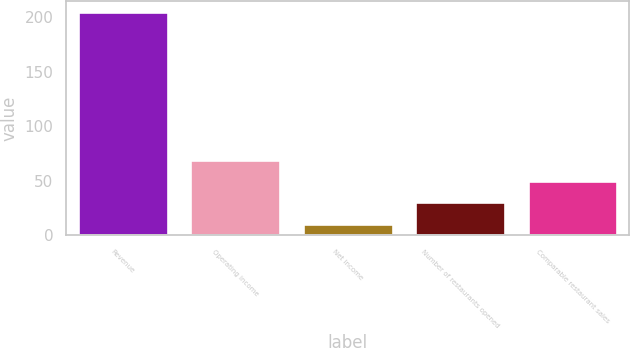Convert chart. <chart><loc_0><loc_0><loc_500><loc_500><bar_chart><fcel>Revenue<fcel>Operating income<fcel>Net income<fcel>Number of restaurants opened<fcel>Comparable restaurant sales<nl><fcel>204.9<fcel>69.03<fcel>10.8<fcel>30.21<fcel>49.62<nl></chart> 